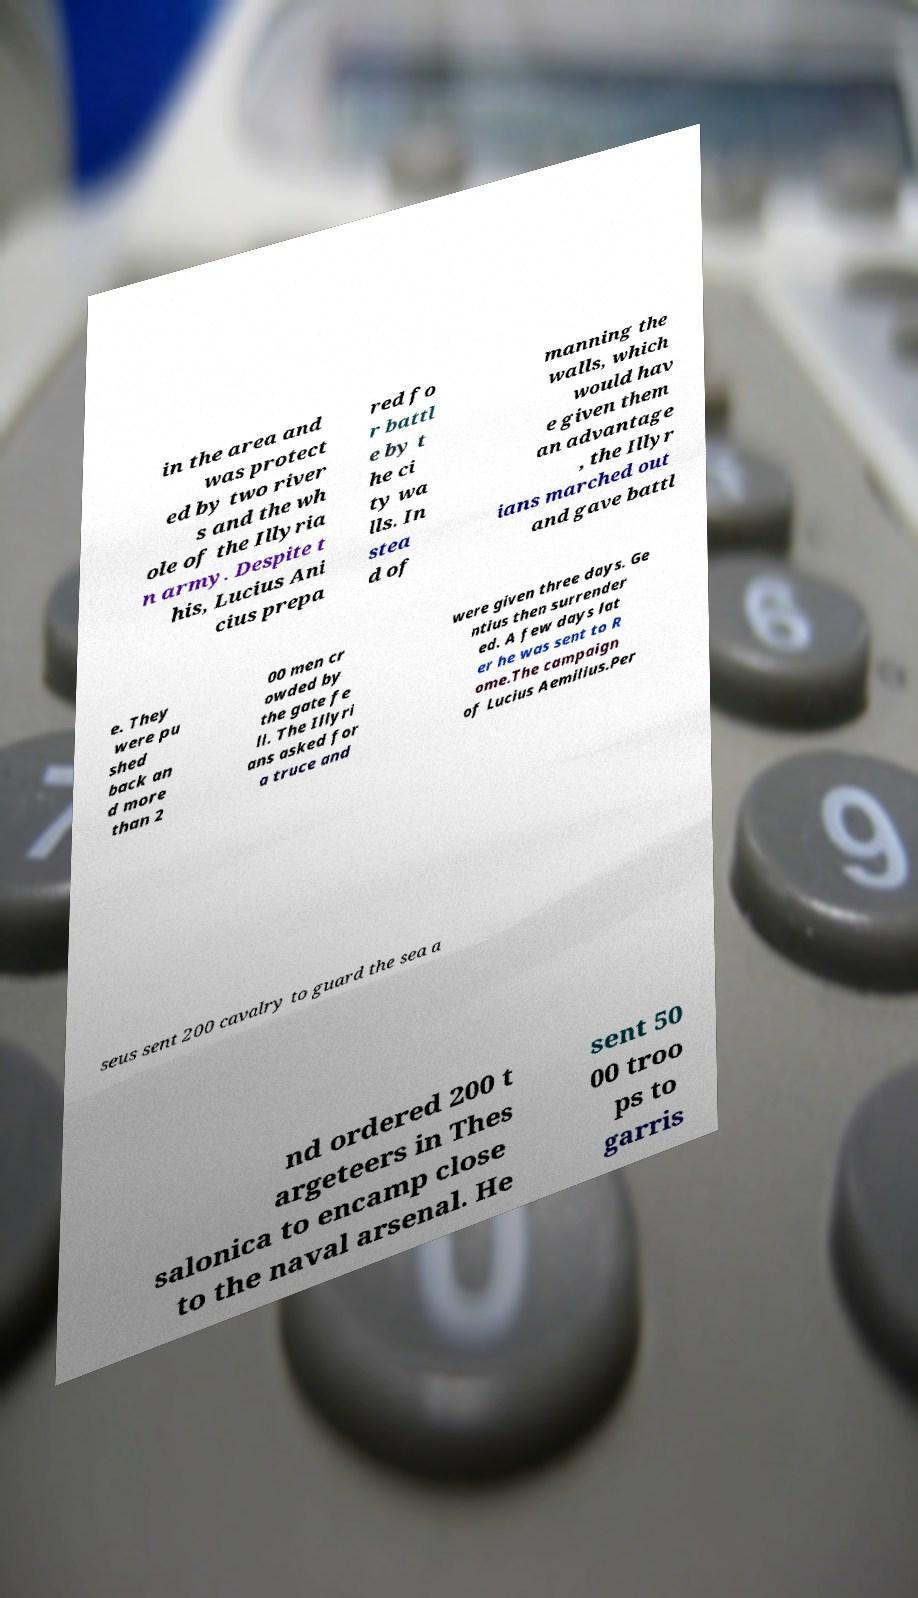I need the written content from this picture converted into text. Can you do that? in the area and was protect ed by two river s and the wh ole of the Illyria n army. Despite t his, Lucius Ani cius prepa red fo r battl e by t he ci ty wa lls. In stea d of manning the walls, which would hav e given them an advantage , the Illyr ians marched out and gave battl e. They were pu shed back an d more than 2 00 men cr owded by the gate fe ll. The Illyri ans asked for a truce and were given three days. Ge ntius then surrender ed. A few days lat er he was sent to R ome.The campaign of Lucius Aemilius.Per seus sent 200 cavalry to guard the sea a nd ordered 200 t argeteers in Thes salonica to encamp close to the naval arsenal. He sent 50 00 troo ps to garris 